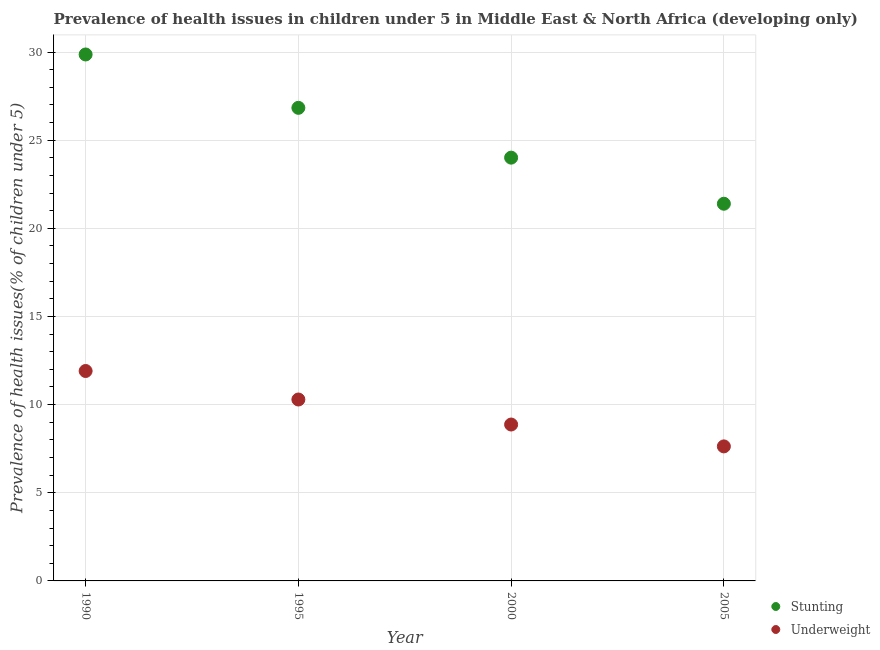What is the percentage of underweight children in 2005?
Make the answer very short. 7.63. Across all years, what is the maximum percentage of underweight children?
Provide a succinct answer. 11.91. Across all years, what is the minimum percentage of underweight children?
Ensure brevity in your answer.  7.63. In which year was the percentage of underweight children maximum?
Your answer should be very brief. 1990. In which year was the percentage of underweight children minimum?
Your answer should be compact. 2005. What is the total percentage of stunted children in the graph?
Provide a short and direct response. 102.1. What is the difference between the percentage of underweight children in 1995 and that in 2000?
Your response must be concise. 1.42. What is the difference between the percentage of stunted children in 1990 and the percentage of underweight children in 2000?
Your response must be concise. 20.99. What is the average percentage of underweight children per year?
Offer a very short reply. 9.67. In the year 1995, what is the difference between the percentage of underweight children and percentage of stunted children?
Your answer should be compact. -16.54. In how many years, is the percentage of underweight children greater than 7 %?
Your response must be concise. 4. What is the ratio of the percentage of stunted children in 1990 to that in 2000?
Provide a short and direct response. 1.24. What is the difference between the highest and the second highest percentage of stunted children?
Offer a terse response. 3.03. What is the difference between the highest and the lowest percentage of stunted children?
Your answer should be compact. 8.47. Is the percentage of underweight children strictly greater than the percentage of stunted children over the years?
Your answer should be compact. No. Is the percentage of stunted children strictly less than the percentage of underweight children over the years?
Your response must be concise. No. How many dotlines are there?
Keep it short and to the point. 2. Where does the legend appear in the graph?
Make the answer very short. Bottom right. How many legend labels are there?
Give a very brief answer. 2. What is the title of the graph?
Ensure brevity in your answer.  Prevalence of health issues in children under 5 in Middle East & North Africa (developing only). Does "Female entrants" appear as one of the legend labels in the graph?
Your answer should be compact. No. What is the label or title of the X-axis?
Give a very brief answer. Year. What is the label or title of the Y-axis?
Your response must be concise. Prevalence of health issues(% of children under 5). What is the Prevalence of health issues(% of children under 5) in Stunting in 1990?
Ensure brevity in your answer.  29.86. What is the Prevalence of health issues(% of children under 5) in Underweight in 1990?
Your response must be concise. 11.91. What is the Prevalence of health issues(% of children under 5) of Stunting in 1995?
Provide a short and direct response. 26.83. What is the Prevalence of health issues(% of children under 5) in Underweight in 1995?
Ensure brevity in your answer.  10.29. What is the Prevalence of health issues(% of children under 5) in Stunting in 2000?
Give a very brief answer. 24.01. What is the Prevalence of health issues(% of children under 5) of Underweight in 2000?
Keep it short and to the point. 8.87. What is the Prevalence of health issues(% of children under 5) in Stunting in 2005?
Keep it short and to the point. 21.39. What is the Prevalence of health issues(% of children under 5) in Underweight in 2005?
Give a very brief answer. 7.63. Across all years, what is the maximum Prevalence of health issues(% of children under 5) of Stunting?
Keep it short and to the point. 29.86. Across all years, what is the maximum Prevalence of health issues(% of children under 5) of Underweight?
Provide a succinct answer. 11.91. Across all years, what is the minimum Prevalence of health issues(% of children under 5) in Stunting?
Your answer should be very brief. 21.39. Across all years, what is the minimum Prevalence of health issues(% of children under 5) in Underweight?
Offer a very short reply. 7.63. What is the total Prevalence of health issues(% of children under 5) in Stunting in the graph?
Ensure brevity in your answer.  102.1. What is the total Prevalence of health issues(% of children under 5) in Underweight in the graph?
Your answer should be compact. 38.7. What is the difference between the Prevalence of health issues(% of children under 5) of Stunting in 1990 and that in 1995?
Your answer should be compact. 3.03. What is the difference between the Prevalence of health issues(% of children under 5) in Underweight in 1990 and that in 1995?
Your response must be concise. 1.62. What is the difference between the Prevalence of health issues(% of children under 5) of Stunting in 1990 and that in 2000?
Give a very brief answer. 5.85. What is the difference between the Prevalence of health issues(% of children under 5) of Underweight in 1990 and that in 2000?
Ensure brevity in your answer.  3.04. What is the difference between the Prevalence of health issues(% of children under 5) of Stunting in 1990 and that in 2005?
Your answer should be very brief. 8.47. What is the difference between the Prevalence of health issues(% of children under 5) of Underweight in 1990 and that in 2005?
Make the answer very short. 4.28. What is the difference between the Prevalence of health issues(% of children under 5) in Stunting in 1995 and that in 2000?
Your response must be concise. 2.83. What is the difference between the Prevalence of health issues(% of children under 5) in Underweight in 1995 and that in 2000?
Your answer should be very brief. 1.42. What is the difference between the Prevalence of health issues(% of children under 5) of Stunting in 1995 and that in 2005?
Give a very brief answer. 5.44. What is the difference between the Prevalence of health issues(% of children under 5) in Underweight in 1995 and that in 2005?
Provide a short and direct response. 2.66. What is the difference between the Prevalence of health issues(% of children under 5) of Stunting in 2000 and that in 2005?
Your response must be concise. 2.61. What is the difference between the Prevalence of health issues(% of children under 5) of Underweight in 2000 and that in 2005?
Your answer should be compact. 1.24. What is the difference between the Prevalence of health issues(% of children under 5) in Stunting in 1990 and the Prevalence of health issues(% of children under 5) in Underweight in 1995?
Offer a very short reply. 19.57. What is the difference between the Prevalence of health issues(% of children under 5) of Stunting in 1990 and the Prevalence of health issues(% of children under 5) of Underweight in 2000?
Provide a short and direct response. 20.99. What is the difference between the Prevalence of health issues(% of children under 5) in Stunting in 1990 and the Prevalence of health issues(% of children under 5) in Underweight in 2005?
Your answer should be compact. 22.23. What is the difference between the Prevalence of health issues(% of children under 5) of Stunting in 1995 and the Prevalence of health issues(% of children under 5) of Underweight in 2000?
Provide a succinct answer. 17.96. What is the difference between the Prevalence of health issues(% of children under 5) in Stunting in 1995 and the Prevalence of health issues(% of children under 5) in Underweight in 2005?
Make the answer very short. 19.2. What is the difference between the Prevalence of health issues(% of children under 5) of Stunting in 2000 and the Prevalence of health issues(% of children under 5) of Underweight in 2005?
Make the answer very short. 16.38. What is the average Prevalence of health issues(% of children under 5) in Stunting per year?
Your response must be concise. 25.52. What is the average Prevalence of health issues(% of children under 5) of Underweight per year?
Ensure brevity in your answer.  9.67. In the year 1990, what is the difference between the Prevalence of health issues(% of children under 5) of Stunting and Prevalence of health issues(% of children under 5) of Underweight?
Offer a terse response. 17.95. In the year 1995, what is the difference between the Prevalence of health issues(% of children under 5) of Stunting and Prevalence of health issues(% of children under 5) of Underweight?
Make the answer very short. 16.54. In the year 2000, what is the difference between the Prevalence of health issues(% of children under 5) in Stunting and Prevalence of health issues(% of children under 5) in Underweight?
Make the answer very short. 15.14. In the year 2005, what is the difference between the Prevalence of health issues(% of children under 5) in Stunting and Prevalence of health issues(% of children under 5) in Underweight?
Your response must be concise. 13.76. What is the ratio of the Prevalence of health issues(% of children under 5) of Stunting in 1990 to that in 1995?
Offer a terse response. 1.11. What is the ratio of the Prevalence of health issues(% of children under 5) in Underweight in 1990 to that in 1995?
Offer a very short reply. 1.16. What is the ratio of the Prevalence of health issues(% of children under 5) of Stunting in 1990 to that in 2000?
Give a very brief answer. 1.24. What is the ratio of the Prevalence of health issues(% of children under 5) in Underweight in 1990 to that in 2000?
Keep it short and to the point. 1.34. What is the ratio of the Prevalence of health issues(% of children under 5) of Stunting in 1990 to that in 2005?
Ensure brevity in your answer.  1.4. What is the ratio of the Prevalence of health issues(% of children under 5) of Underweight in 1990 to that in 2005?
Offer a terse response. 1.56. What is the ratio of the Prevalence of health issues(% of children under 5) in Stunting in 1995 to that in 2000?
Keep it short and to the point. 1.12. What is the ratio of the Prevalence of health issues(% of children under 5) in Underweight in 1995 to that in 2000?
Your answer should be very brief. 1.16. What is the ratio of the Prevalence of health issues(% of children under 5) in Stunting in 1995 to that in 2005?
Provide a succinct answer. 1.25. What is the ratio of the Prevalence of health issues(% of children under 5) in Underweight in 1995 to that in 2005?
Your answer should be very brief. 1.35. What is the ratio of the Prevalence of health issues(% of children under 5) in Stunting in 2000 to that in 2005?
Provide a succinct answer. 1.12. What is the ratio of the Prevalence of health issues(% of children under 5) in Underweight in 2000 to that in 2005?
Your response must be concise. 1.16. What is the difference between the highest and the second highest Prevalence of health issues(% of children under 5) of Stunting?
Make the answer very short. 3.03. What is the difference between the highest and the second highest Prevalence of health issues(% of children under 5) in Underweight?
Offer a terse response. 1.62. What is the difference between the highest and the lowest Prevalence of health issues(% of children under 5) in Stunting?
Offer a terse response. 8.47. What is the difference between the highest and the lowest Prevalence of health issues(% of children under 5) in Underweight?
Your response must be concise. 4.28. 